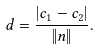Convert formula to latex. <formula><loc_0><loc_0><loc_500><loc_500>d = \frac { | c _ { 1 } - c _ { 2 } | } { \| n \| } .</formula> 